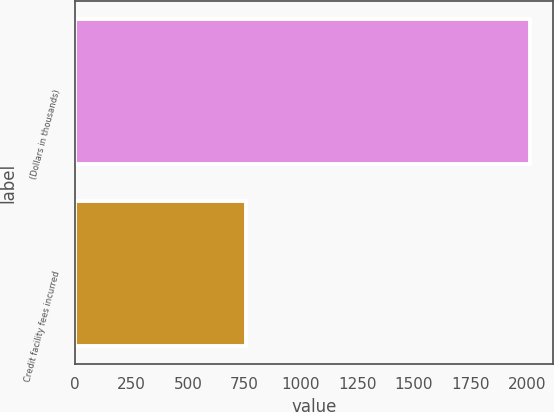Convert chart to OTSL. <chart><loc_0><loc_0><loc_500><loc_500><bar_chart><fcel>(Dollars in thousands)<fcel>Credit facility fees incurred<nl><fcel>2015<fcel>756<nl></chart> 